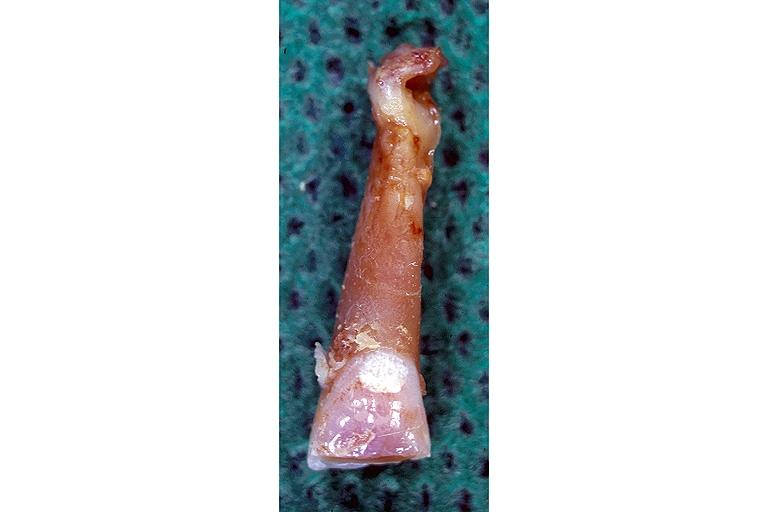where is this?
Answer the question using a single word or phrase. Oral 